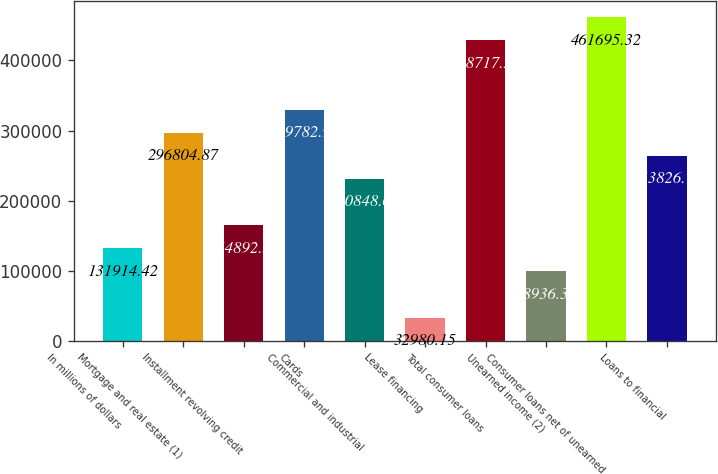Convert chart to OTSL. <chart><loc_0><loc_0><loc_500><loc_500><bar_chart><fcel>In millions of dollars<fcel>Mortgage and real estate (1)<fcel>Installment revolving credit<fcel>Cards<fcel>Commercial and industrial<fcel>Lease financing<fcel>Total consumer loans<fcel>Unearned income (2)<fcel>Consumer loans net of unearned<fcel>Loans to financial<nl><fcel>131914<fcel>296805<fcel>164893<fcel>329783<fcel>230849<fcel>32980.2<fcel>428717<fcel>98936.3<fcel>461695<fcel>263827<nl></chart> 